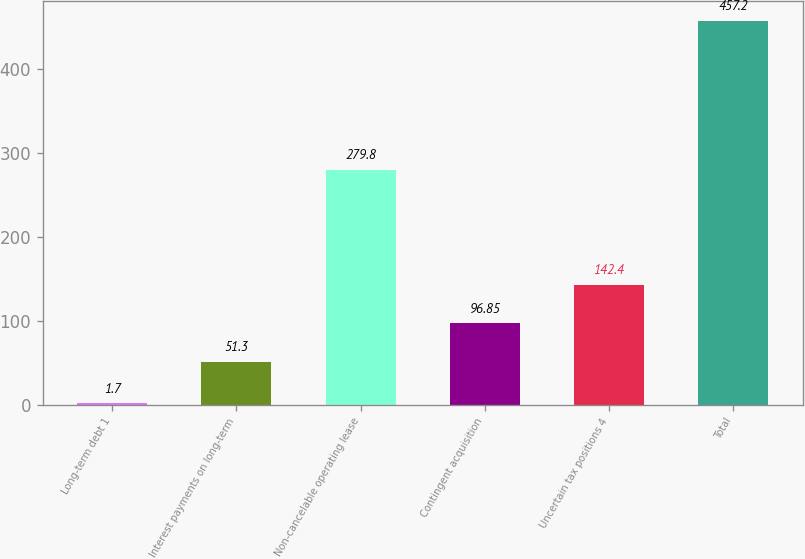Convert chart. <chart><loc_0><loc_0><loc_500><loc_500><bar_chart><fcel>Long-term debt 1<fcel>Interest payments on long-term<fcel>Non-cancelable operating lease<fcel>Contingent acquisition<fcel>Uncertain tax positions 4<fcel>Total<nl><fcel>1.7<fcel>51.3<fcel>279.8<fcel>96.85<fcel>142.4<fcel>457.2<nl></chart> 